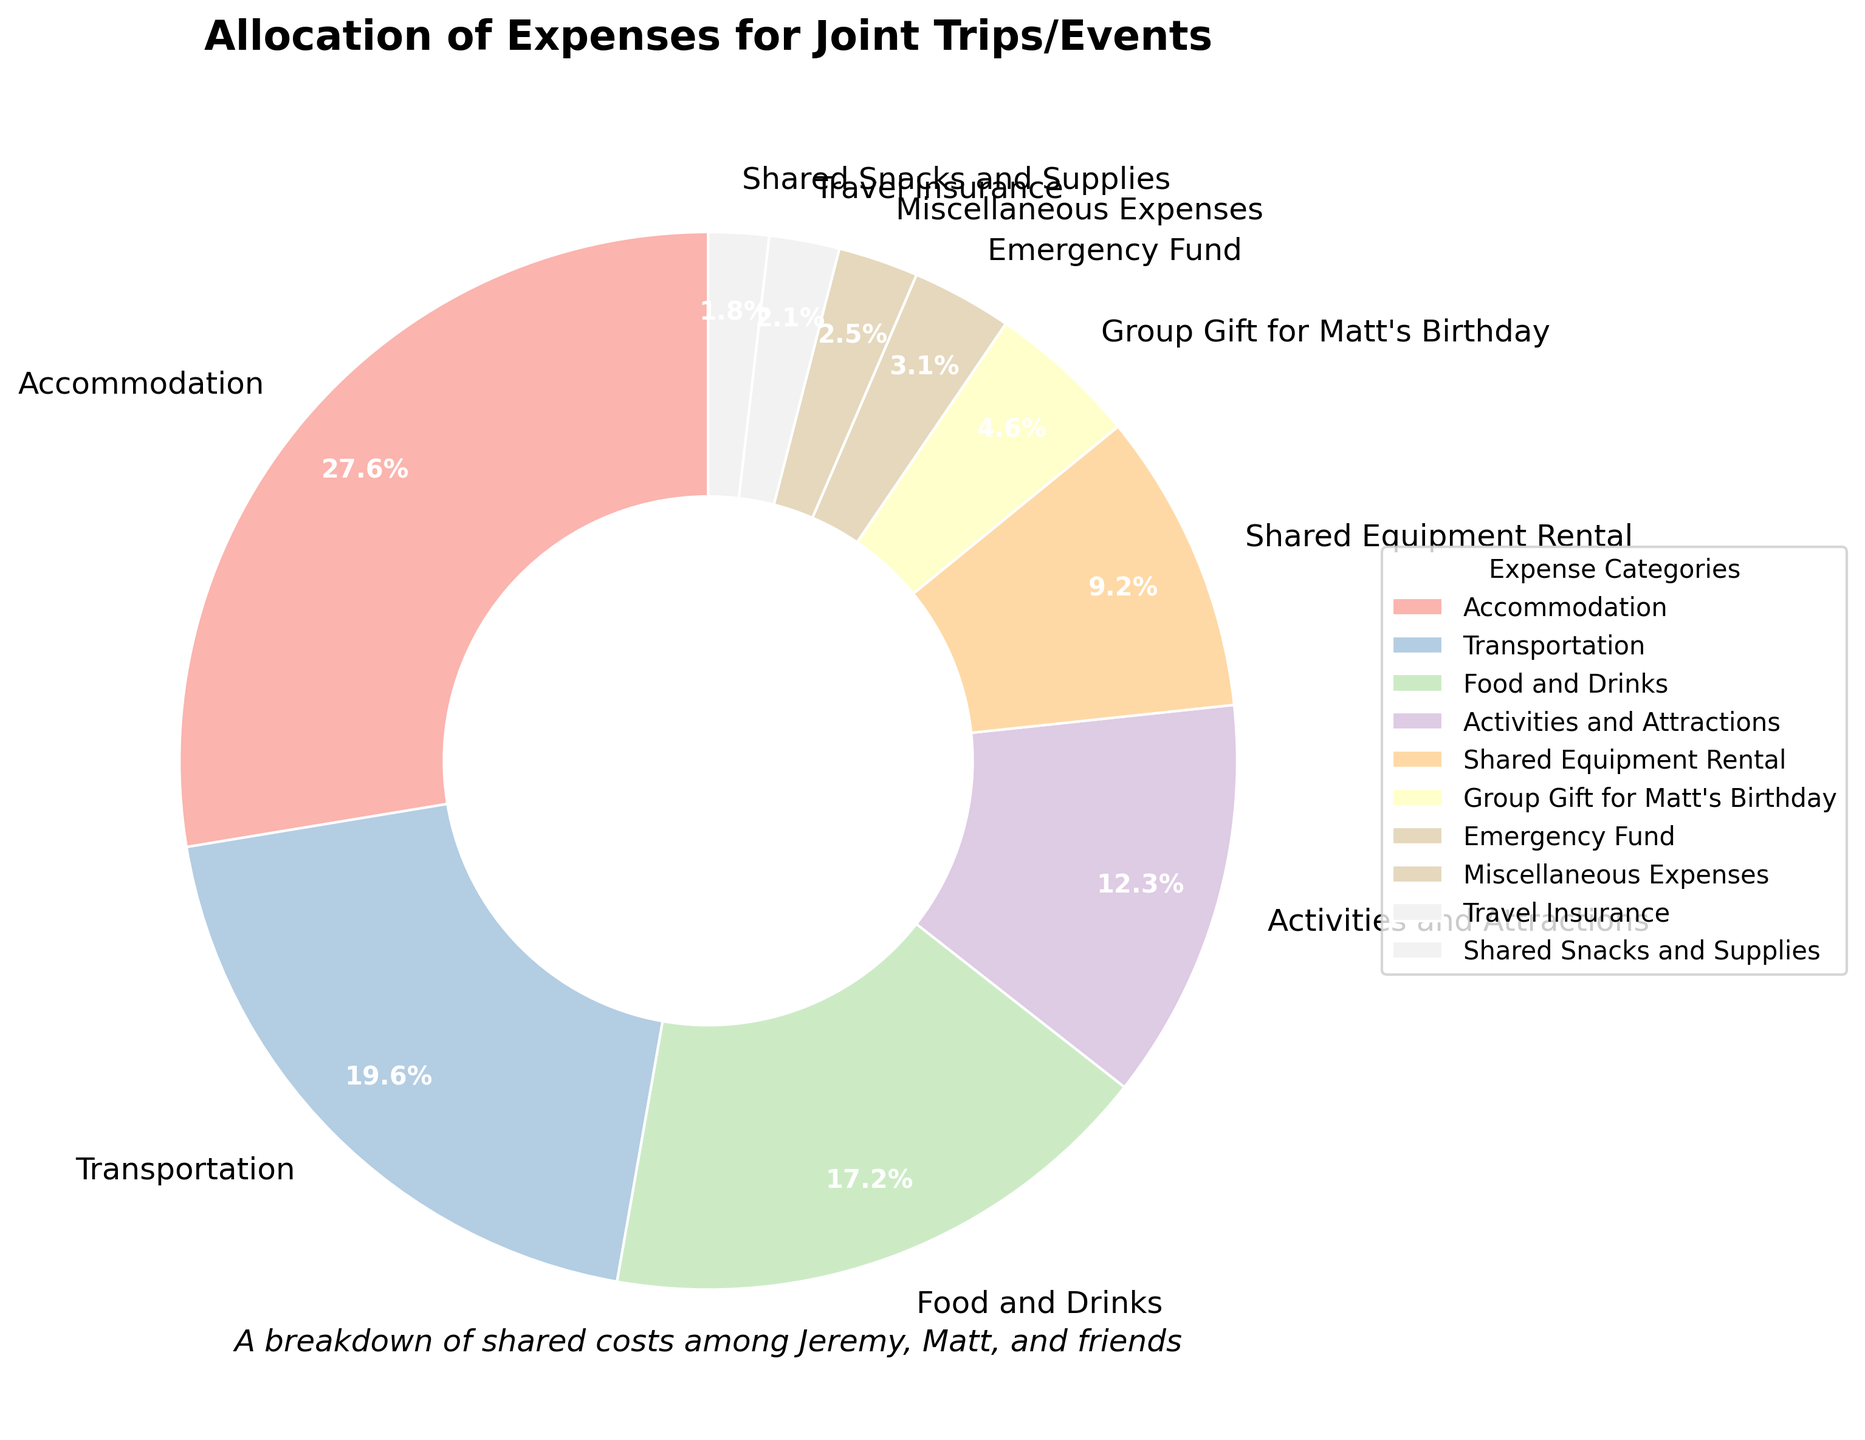How much more was spent on Accommodation compared to Food and Drinks? To find this, we look at the pie chart and identify the amounts for Accommodation and Food and Drinks. Accommodation is $450 and Food and Drinks is $280. The difference is $450 - $280 = $170.
Answer: $170 Which category represents the smallest portion of the expenses? By examining the pie chart, we can see that Shared Snacks and Supplies, with an amount of $30, represents the smallest portion of the expenses.
Answer: Shared Snacks and Supplies What is the combined percentage of spending on Activities and Attractions and Shared Equipment Rental? First, find the percentages of both categories from the pie chart. Activities and Attractions is 12.2%, and Shared Equipment Rental is 9.2%. Adding these together, 12.2% + 9.2% = 21.4%.
Answer: 21.4% Which expense category has a larger portion: Emergency Fund or Travel Insurance? By checking the pie chart, we see that Emergency Fund accounts for 3.1% while Travel Insurance accounts for 2.1%. Thus, Emergency Fund has a larger portion.
Answer: Emergency Fund If the budget for Food and Drinks had been reallocated to Transportation, what would Transportation's new total be? Food and Drinks account for $280, and Transportation is $320. Adding these amounts together, $320 + $280 = $600.
Answer: $600 Are there any categories with an amount less than $100? We look at the expense amounts in the pie chart. Group Gift for Matt's Birthday ($75), Emergency Fund ($50), Miscellaneous Expenses ($40), Travel Insurance ($35), and Shared Snacks and Supplies ($30) are all below $100.
Answer: Yes What percentage of the total budget is allocated to Accommodation and Transportation combined? From the pie chart, we know Accommodation is 34.1% and Transportation is 24.2%. Adding these together yields 34.1% + 24.2% = 58.3%.
Answer: 58.3% Compare the shared expenses for Miscellaneous Expenses and Travel Insurance. Which one is higher, and by how much? The pie chart indicates Miscellaneous Expenses ($40) and Travel Insurance ($35). Miscellaneous Expenses are higher by $40 - $35 = $5.
Answer: Miscellaneous Expenses by $5 